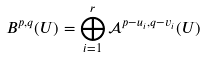Convert formula to latex. <formula><loc_0><loc_0><loc_500><loc_500>B ^ { p , q } ( U ) = \bigoplus _ { i = 1 } ^ { r } \mathcal { A } ^ { p - u _ { i } , q - v _ { i } } ( U )</formula> 